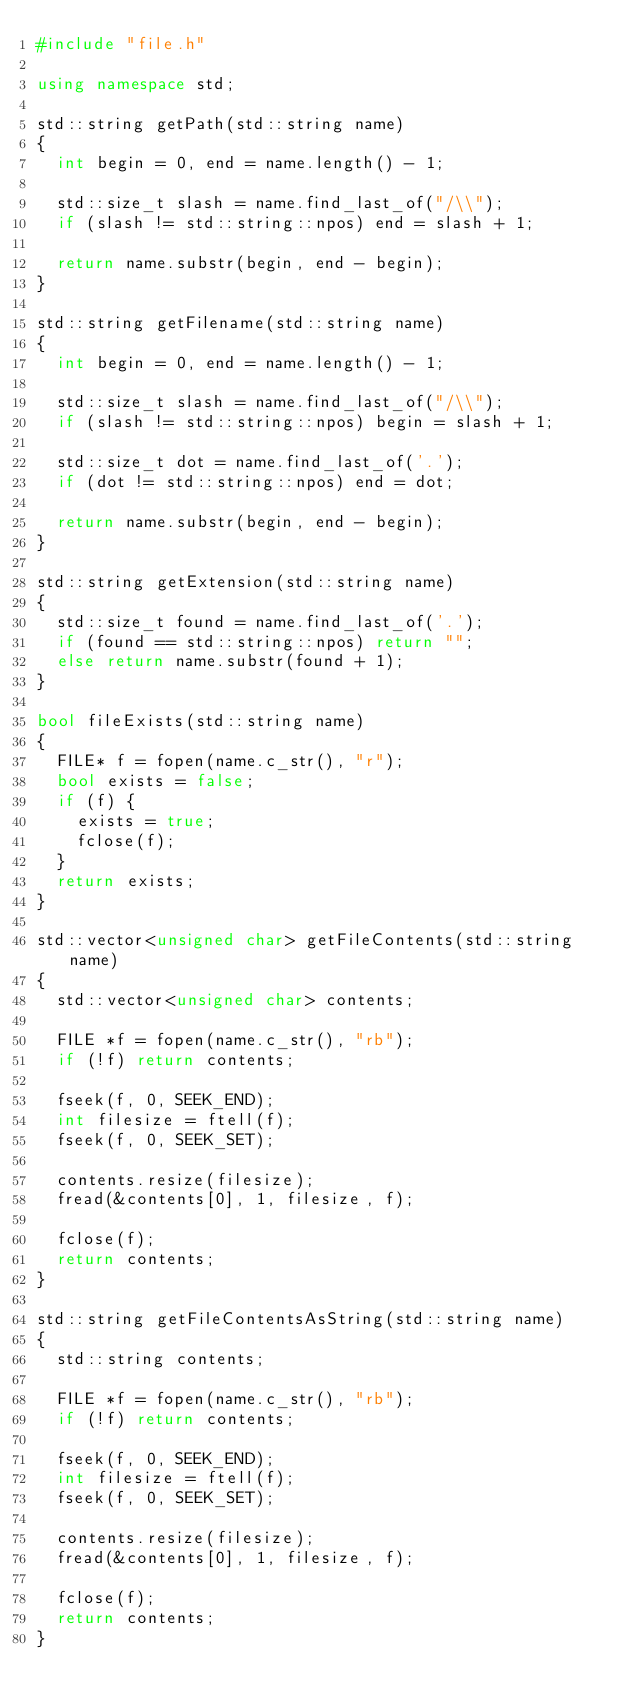<code> <loc_0><loc_0><loc_500><loc_500><_C++_>#include "file.h"

using namespace std;

std::string getPath(std::string name)
{
	int begin = 0, end = name.length() - 1;

	std::size_t slash = name.find_last_of("/\\");
	if (slash != std::string::npos) end = slash + 1;

	return name.substr(begin, end - begin);
}

std::string getFilename(std::string name)
{
	int begin = 0, end = name.length() - 1;

	std::size_t slash = name.find_last_of("/\\");
	if (slash != std::string::npos) begin = slash + 1;

	std::size_t dot = name.find_last_of('.');
	if (dot != std::string::npos) end = dot;

	return name.substr(begin, end - begin);
}

std::string getExtension(std::string name)
{
	std::size_t found = name.find_last_of('.');
	if (found == std::string::npos) return "";
	else return name.substr(found + 1);
}

bool fileExists(std::string name)
{
	FILE* f = fopen(name.c_str(), "r");
	bool exists = false;
	if (f) {
		exists = true;
		fclose(f);
	}
	return exists;
}

std::vector<unsigned char> getFileContents(std::string name)
{
	std::vector<unsigned char> contents;

	FILE *f = fopen(name.c_str(), "rb");
	if (!f) return contents;

	fseek(f, 0, SEEK_END);
	int filesize = ftell(f);
	fseek(f, 0, SEEK_SET);

	contents.resize(filesize);
	fread(&contents[0], 1, filesize, f);

	fclose(f);
	return contents;
}

std::string getFileContentsAsString(std::string name)
{
	std::string contents;

	FILE *f = fopen(name.c_str(), "rb");
	if (!f) return contents;

	fseek(f, 0, SEEK_END);
	int filesize = ftell(f);
	fseek(f, 0, SEEK_SET);

	contents.resize(filesize);
	fread(&contents[0], 1, filesize, f);

	fclose(f);
	return contents;
}</code> 